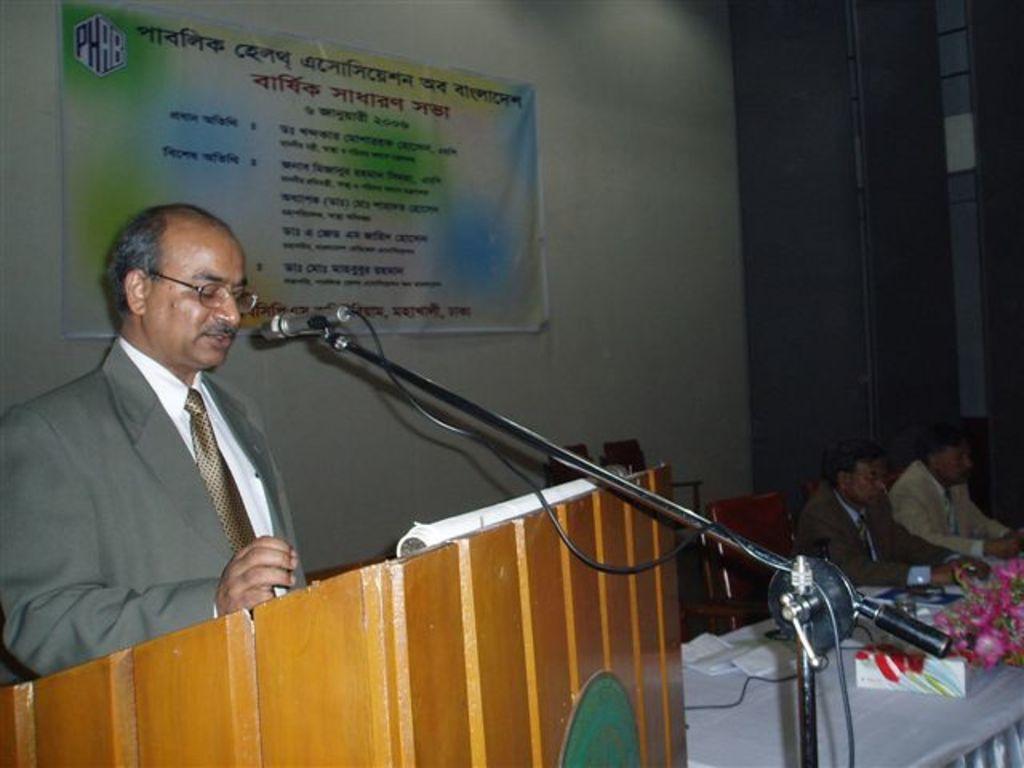Describe this image in one or two sentences. In the foreground of the picture there is a mic, cable, podium and a person standing and talking. In the center of the there are table, flower vase, people, chairs and other objects. At the top there is a banner. 